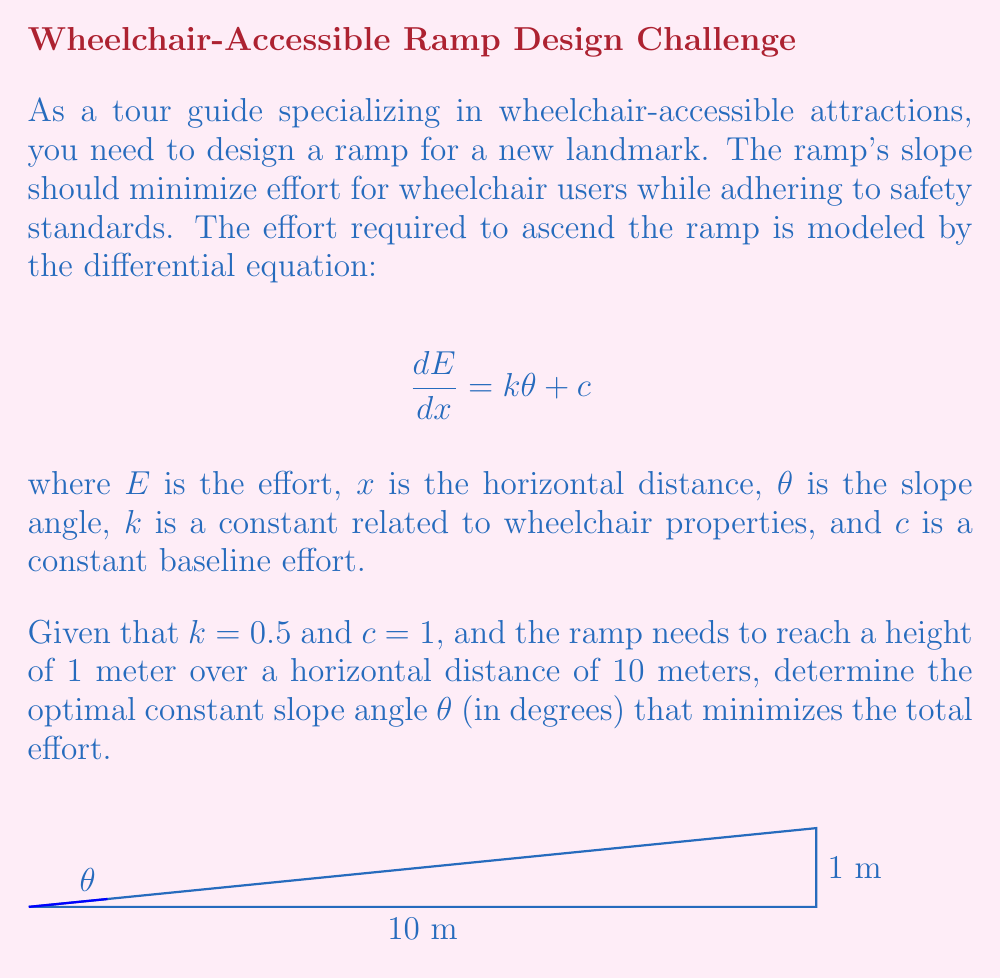Show me your answer to this math problem. To solve this problem, we'll follow these steps:

1) First, we need to express $\theta$ in terms of the given dimensions:
   $$\tan(\theta) = \frac{1}{10} = 0.1$$

2) The total effort is the integral of $\frac{dE}{dx}$ over the length of the ramp:
   $$E = \int_0^{10} (k\theta + c) dx = (k\theta + c)x \bigg|_0^{10} = 10(k\theta + c)$$

3) Substitute the given values:
   $$E = 10(0.5\theta + 1)$$

4) To minimize effort, we need to find the value of $\theta$ that minimizes this expression. In calculus, we'd take the derivative and set it to zero, but here we can observe that the effort increases linearly with $\theta$. Therefore, the minimum effort occurs at the smallest allowable $\theta$.

5) The smallest allowable $\theta$ is the one that satisfies the height requirement:
   $$\theta = \arctan(0.1) \approx 5.71 degrees$$

6) This angle is within typical accessibility guidelines (usually max 4.8° or 1:12 slope), so it's acceptable.

Therefore, the optimal constant slope angle is approximately 5.71°.
Answer: $5.71°$ 